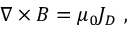<formula> <loc_0><loc_0><loc_500><loc_500>{ \nabla \times B } = \mu _ { 0 } { J _ { D } } \ ,</formula> 